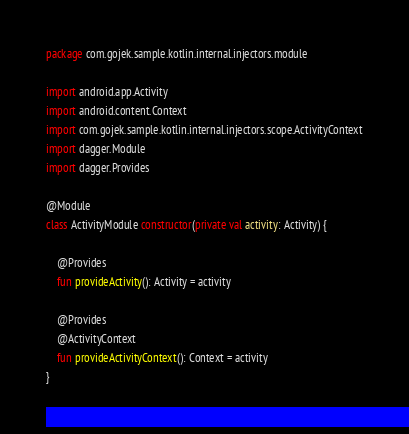<code> <loc_0><loc_0><loc_500><loc_500><_Kotlin_>package com.gojek.sample.kotlin.internal.injectors.module

import android.app.Activity
import android.content.Context
import com.gojek.sample.kotlin.internal.injectors.scope.ActivityContext
import dagger.Module
import dagger.Provides

@Module
class ActivityModule constructor(private val activity: Activity) {

    @Provides
    fun provideActivity(): Activity = activity

    @Provides
    @ActivityContext
    fun provideActivityContext(): Context = activity
}</code> 